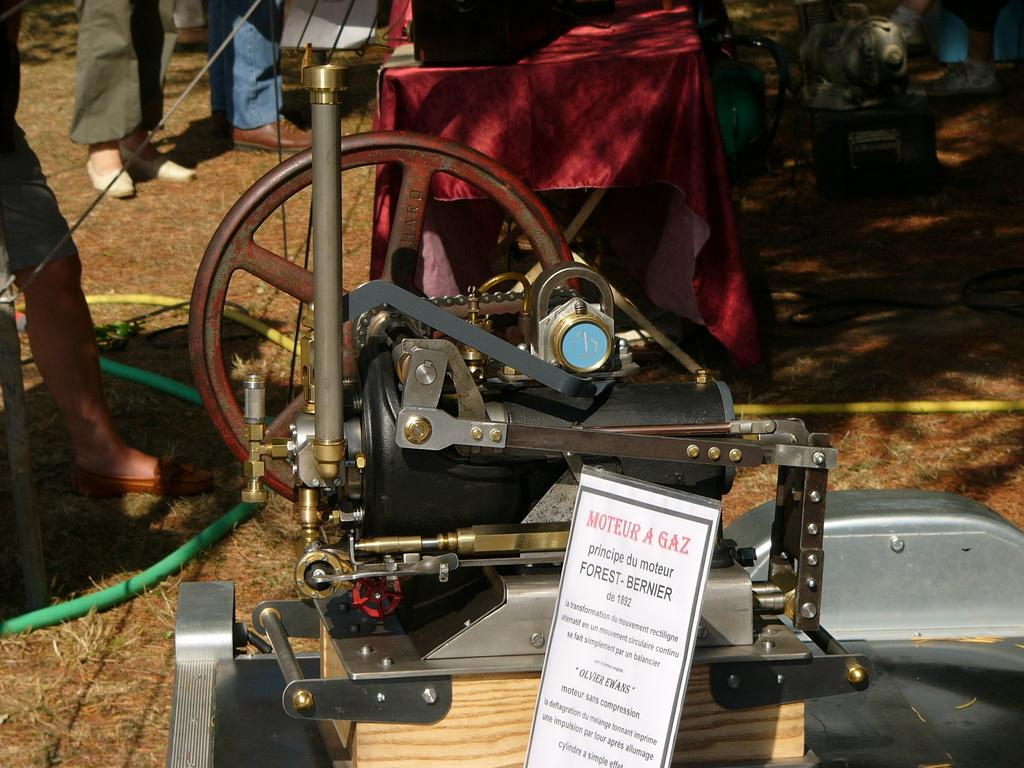What is the main subject of the picture? The main subject of the picture is a machine. What can be seen connected to the machine? There are pipes visible in the picture. What else is present on the ground in the picture? There are other objects on the ground in the picture. Are there any people in the picture? Yes, there are people standing on the ground in the picture. What type of flag is being used to control the expansion of the machine in the image? There is no flag present in the image, and the machine is not expanding. 